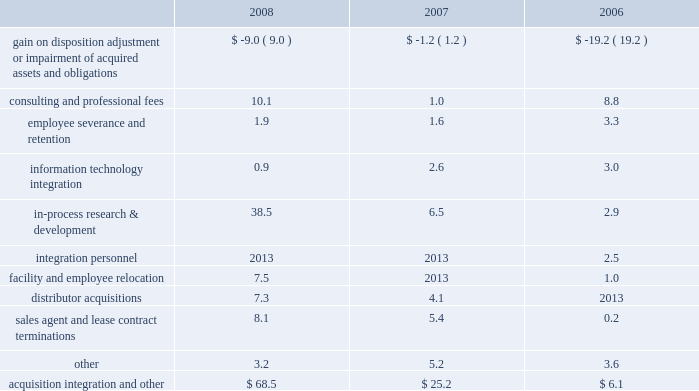December 31 , 2008 , 2007 and 2006 , included ( in millions ) : .
Included in the gain on disposition , adjustment or impairment of acquired assets and obligations for 2008 is a favorable adjustment to certain liabilities of acquired companies due to changes in circumstances surrounding those liabilities subsequent to the related measurement period .
Included in the gain on disposition , adjustment or impairment of acquired assets and obligations for 2006 is the sale of the former centerpulse austin land and facilities for a gain of $ 5.1 million and the favorable settlement of two pre- acquisition contingent liabilities .
These gains were offset by a $ 13.4 million impairment charge for certain centerpulse tradename and trademark intangibles based principally in our europe operating segment .
In-process research and development charges for 2008 are related to the acquisition of abbott spine .
In-process research and development charges for 2007 are related to the acquisitions of endius and orthosoft .
Consulting and professional fees relate to third- party integration consulting performed in a variety of areas such as tax , compliance , logistics and human resources and legal fees related to matters involving acquired businesses .
Cash and equivalents 2013 we consider all highly liquid investments with an original maturity of three months or less to be cash equivalents .
The carrying amounts reported in the balance sheet for cash and equivalents are valued at cost , which approximates their fair value .
Restricted cash is primarily composed of cash held in escrow related to certain insurance coverage .
Inventories 2013 inventories , net of allowances for obsolete and slow-moving goods , are stated at the lower of cost or market , with cost determined on a first-in first-out basis .
Property , plant and equipment 2013 property , plant and equipment is carried at cost less accumulated depreciation .
Depreciation is computed using the straight-line method based on estimated useful lives of ten to forty years for buildings and improvements , three to eight years for machinery and equipment .
Maintenance and repairs are expensed as incurred .
In accordance with statement of financial accounting standards ( 201csfas 201d ) no .
144 , 201caccounting for the impairment or disposal of long-lived assets , 201d we review property , plant and equipment for impairment whenever events or changes in circumstances indicate that the carrying value of an asset may not be recoverable .
An impairment loss would be recognized when estimated future undiscounted cash flows relating to the asset are less than its carrying amount .
An impairment loss is measured as the amount by which the carrying amount of an asset exceeds its fair value .
Software costs 2013 we capitalize certain computer software and software development costs incurred in connection with developing or obtaining computer software for internal use when both the preliminary project stage is completed and it is probable that the software will be used as intended .
Capitalized software costs generally include external direct costs of materials and services utilized in developing or obtaining computer software and compensation and related benefits for employees who are directly associated with the software project .
Capitalized software costs are included in property , plant and equipment on our balance sheet and amortized on a straight-line basis when the software is ready for its intended use over the estimated useful lives of the software , which approximate three to seven years .
Instruments 2013 instruments are hand-held devices used by orthopaedic surgeons during total joint replacement and other surgical procedures .
Instruments are recognized as long-lived assets and are included in property , plant and equipment .
Undeployed instruments are carried at cost , net of allowances for excess and obsolete instruments .
Instruments in the field are carried at cost less accumulated depreciation .
Depreciation is computed using the straight-line method based on average estimated useful lives , determined principally in reference to associated product life cycles , primarily five years .
We review instruments for impairment in accordance with sfas no .
144 .
Depreciation of instruments is recognized as selling , general and administrative expense .
Goodwill 2013 we account for goodwill in accordance with sfas no .
142 , 201cgoodwill and other intangible assets . 201d goodwill is not amortized but is subject to annual impairment tests .
Goodwill has been assigned to reporting units .
We perform annual impairment tests by comparing each reporting unit 2019s fair value to its carrying amount to determine if there is potential impairment .
The fair value of the reporting unit and the implied fair value of goodwill are determined based upon a discounted cash flow analysis .
Significant assumptions are incorporated into to these discounted cash flow analyses such as estimated growth rates and risk-adjusted discount rates .
We perform this test in the fourth quarter of the year .
If the fair value of the reporting unit is less than its carrying value , an impairment loss is recorded to the extent that the implied fair value of the reporting unit goodwill is less than the carrying value of the reporting unit goodwill .
Intangible assets 2013 we account for intangible assets in accordance with sfas no .
142 .
Intangible assets are initially measured at their fair value .
We have determined the fair value of our intangible assets either by the fair value of the z i m m e r h o l d i n g s , i n c .
2 0 0 8 f o r m 1 0 - k a n n u a l r e p o r t notes to consolidated financial statements ( continued ) %%transmsg*** transmitting job : c48761 pcn : 044000000 ***%%pcmsg|44 |00007|yes|no|02/24/2009 06:10|0|0|page is valid , no graphics -- color : d| .
What is the sale of the former centerpulse austin land and facilities as a percentage of the gain on disposition adjustment or impairment of acquired assets and obligations in 2006? 
Computations: (5.1 / 19.2)
Answer: 0.26562. 